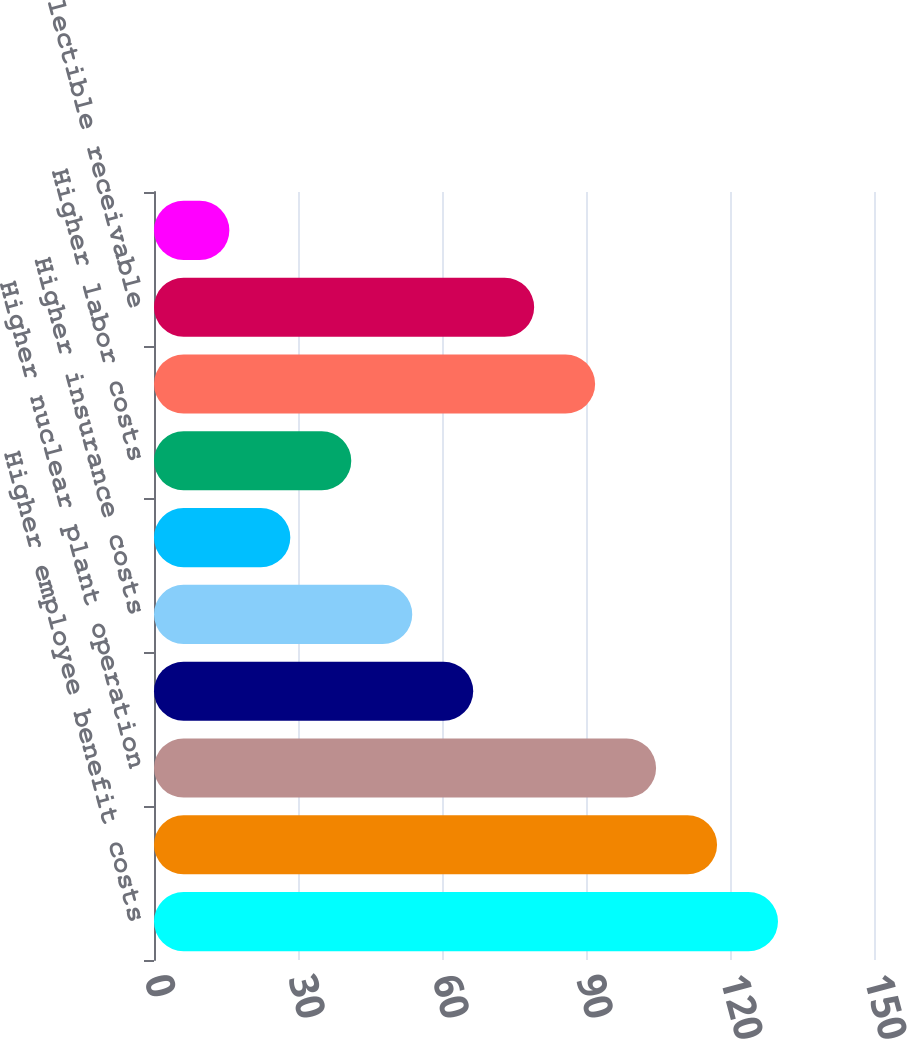<chart> <loc_0><loc_0><loc_500><loc_500><bar_chart><fcel>Higher employee benefit costs<fcel>Nuclear outage costs net of<fcel>Higher nuclear plant operation<fcel>Higher plant generation costs<fcel>Higher insurance costs<fcel>Higher information technology<fcel>Higher labor costs<fcel>Lower consulting costs<fcel>Lower uncollectible receivable<fcel>Lower material costs<nl><fcel>130<fcel>117.3<fcel>104.6<fcel>66.5<fcel>53.8<fcel>28.4<fcel>41.1<fcel>91.9<fcel>79.2<fcel>15.7<nl></chart> 